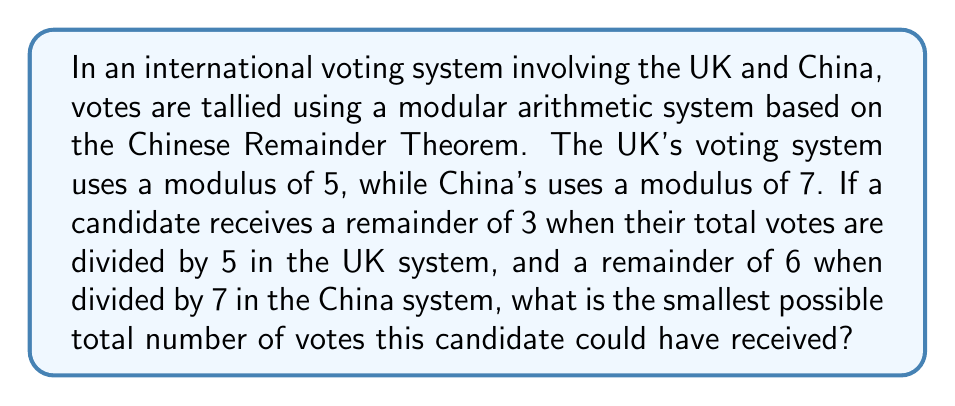What is the answer to this math problem? To solve this problem, we'll use the Chinese Remainder Theorem (CRT). Let's approach this step-by-step:

1) We have two congruences:
   $x \equiv 3 \pmod{5}$
   $x \equiv 6 \pmod{7}$

2) Let $M = 5 \times 7 = 35$ be the product of the moduli.

3) We need to find $M_1 = M/5 = 7$ and $M_2 = M/7 = 5$.

4) Next, we find the modular multiplicative inverses:
   $7^{-1} \equiv 3 \pmod{5}$ (because $7 \times 3 \equiv 1 \pmod{5}$)
   $5^{-1} \equiv 3 \pmod{7}$ (because $5 \times 3 \equiv 1 \pmod{7}$)

5) Now we can apply the CRT formula:
   $x \equiv (3 \times 7 \times 3 + 6 \times 5 \times 3) \pmod{35}$

6) Simplifying:
   $x \equiv (63 + 90) \pmod{35}$
   $x \equiv 153 \pmod{35}$
   $x \equiv 13 \pmod{35}$

7) Therefore, the smallest positive solution is 13.

We can verify:
13 ÷ 5 = 2 remainder 3
13 ÷ 7 = 1 remainder 6

Thus, 13 is the smallest number of votes that satisfies both conditions.
Answer: 13 votes 